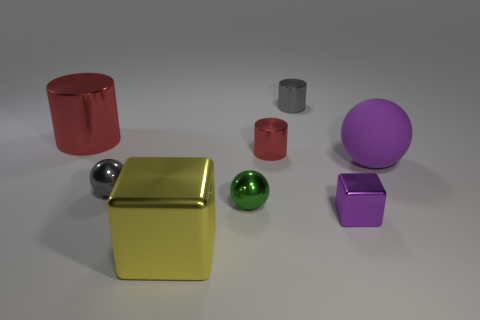Are there fewer large yellow metal things to the right of the green thing than tiny green things?
Offer a very short reply. Yes. There is a tiny object that is the same color as the large sphere; what is its shape?
Your response must be concise. Cube. How many shiny blocks are the same size as the rubber sphere?
Give a very brief answer. 1. The large metal thing in front of the large red cylinder has what shape?
Provide a succinct answer. Cube. Is the number of red metal things less than the number of small rubber balls?
Provide a short and direct response. No. Is there any other thing of the same color as the big ball?
Make the answer very short. Yes. What is the size of the block that is on the right side of the small green thing?
Keep it short and to the point. Small. Is the number of green metallic objects greater than the number of small yellow metallic blocks?
Give a very brief answer. Yes. What is the purple sphere made of?
Ensure brevity in your answer.  Rubber. How many other objects are the same material as the yellow object?
Make the answer very short. 6. 